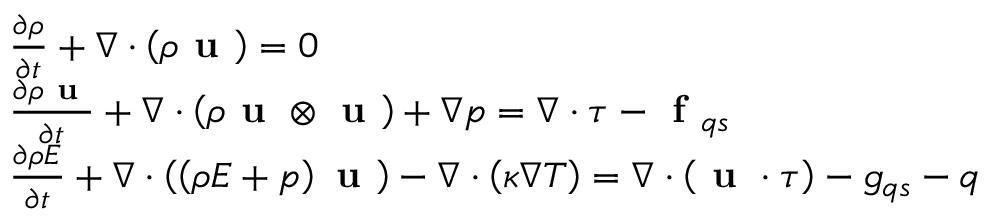<formula> <loc_0><loc_0><loc_500><loc_500>\begin{array} { r l } & { \frac { \partial \rho } { \partial t } + \nabla \cdot \left ( \rho u \right ) = 0 } \\ & { \frac { \partial \rho u } { \partial t } + \nabla \cdot \left ( \rho u \otimes u \right ) + \nabla p = \nabla \cdot \tau - f _ { q s } } \\ & { \frac { \partial \rho E } { \partial t } + \nabla \cdot \left ( \left ( \rho E + p \right ) u \right ) - \nabla \cdot \left ( \kappa \nabla T \right ) = \nabla \cdot \left ( u \cdot \tau \right ) - g _ { q s } - q } \end{array}</formula> 